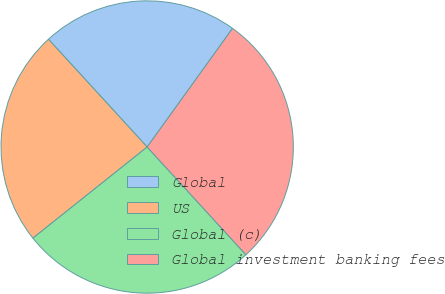Convert chart. <chart><loc_0><loc_0><loc_500><loc_500><pie_chart><fcel>Global<fcel>US<fcel>Global (c)<fcel>Global investment banking fees<nl><fcel>21.74%<fcel>23.91%<fcel>26.09%<fcel>28.26%<nl></chart> 